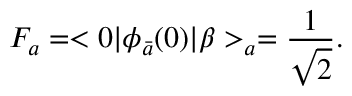Convert formula to latex. <formula><loc_0><loc_0><loc_500><loc_500>F _ { a } = < 0 | \phi _ { \bar { a } } ( 0 ) | \beta > _ { a } = \frac { 1 } { \sqrt { 2 } } .</formula> 